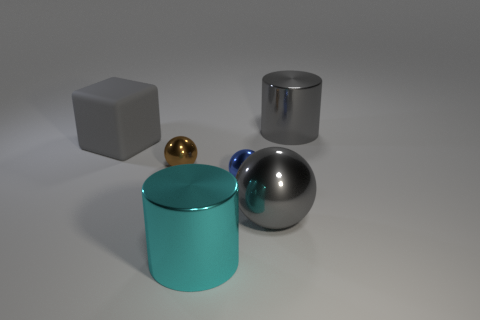Is there anything else that is the same material as the gray cube?
Keep it short and to the point. No. There is a big ball that is made of the same material as the tiny blue object; what is its color?
Your answer should be very brief. Gray. What number of large cylinders are the same color as the large block?
Your answer should be very brief. 1. How many things are either brown spheres or large red shiny cylinders?
Provide a short and direct response. 1. The cyan thing that is the same size as the gray metallic cylinder is what shape?
Your response must be concise. Cylinder. What number of metallic things are both behind the small brown thing and in front of the large gray metal cylinder?
Your response must be concise. 0. There is a large cylinder that is behind the big gray matte object; what is its material?
Make the answer very short. Metal. What size is the blue sphere that is the same material as the cyan object?
Offer a terse response. Small. There is a gray object behind the rubber object; is it the same size as the blue metallic sphere that is on the right side of the big cyan shiny thing?
Make the answer very short. No. There is a cyan thing that is the same size as the gray ball; what is its material?
Give a very brief answer. Metal. 